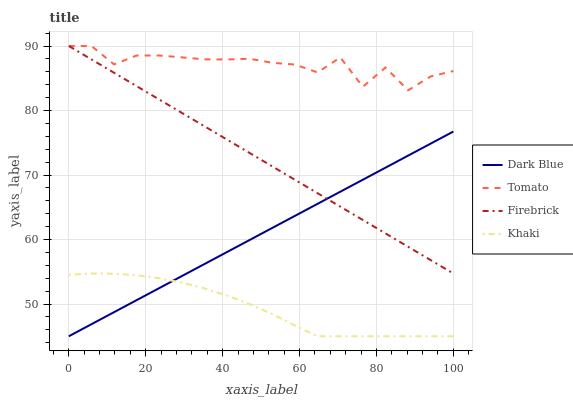Does Khaki have the minimum area under the curve?
Answer yes or no. Yes. Does Tomato have the maximum area under the curve?
Answer yes or no. Yes. Does Dark Blue have the minimum area under the curve?
Answer yes or no. No. Does Dark Blue have the maximum area under the curve?
Answer yes or no. No. Is Firebrick the smoothest?
Answer yes or no. Yes. Is Tomato the roughest?
Answer yes or no. Yes. Is Dark Blue the smoothest?
Answer yes or no. No. Is Dark Blue the roughest?
Answer yes or no. No. Does Dark Blue have the lowest value?
Answer yes or no. Yes. Does Firebrick have the lowest value?
Answer yes or no. No. Does Firebrick have the highest value?
Answer yes or no. Yes. Does Dark Blue have the highest value?
Answer yes or no. No. Is Khaki less than Firebrick?
Answer yes or no. Yes. Is Tomato greater than Dark Blue?
Answer yes or no. Yes. Does Tomato intersect Firebrick?
Answer yes or no. Yes. Is Tomato less than Firebrick?
Answer yes or no. No. Is Tomato greater than Firebrick?
Answer yes or no. No. Does Khaki intersect Firebrick?
Answer yes or no. No. 